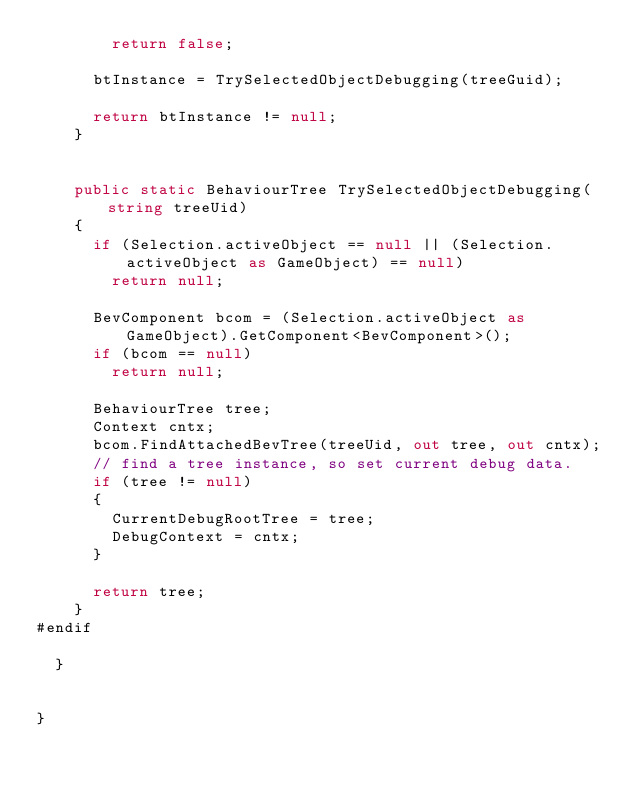<code> <loc_0><loc_0><loc_500><loc_500><_C#_>				return false;

			btInstance = TrySelectedObjectDebugging(treeGuid);

			return btInstance != null;
		}


		public static BehaviourTree TrySelectedObjectDebugging(string treeUid)
		{
			if (Selection.activeObject == null || (Selection.activeObject as GameObject) == null)
				return null;

			BevComponent bcom = (Selection.activeObject as GameObject).GetComponent<BevComponent>();
			if (bcom == null)
				return null;

			BehaviourTree tree;
			Context cntx;
			bcom.FindAttachedBevTree(treeUid, out tree, out cntx);
			// find a tree instance, so set current debug data.
			if (tree != null)
			{
				CurrentDebugRootTree = tree;
				DebugContext = cntx;
			}

			return tree;
		}
#endif

	}


}</code> 